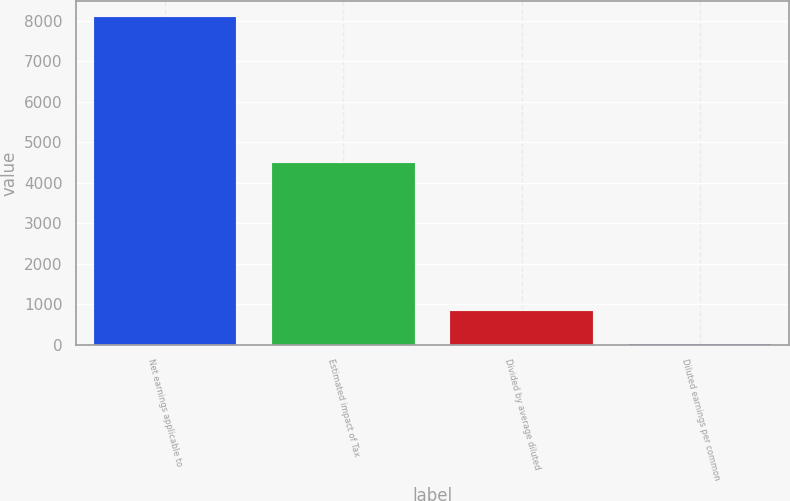<chart> <loc_0><loc_0><loc_500><loc_500><bar_chart><fcel>Net earnings applicable to<fcel>Estimated impact of Tax<fcel>Divided by average diluted<fcel>Diluted earnings per common<nl><fcel>8085<fcel>4491.52<fcel>826.28<fcel>19.76<nl></chart> 